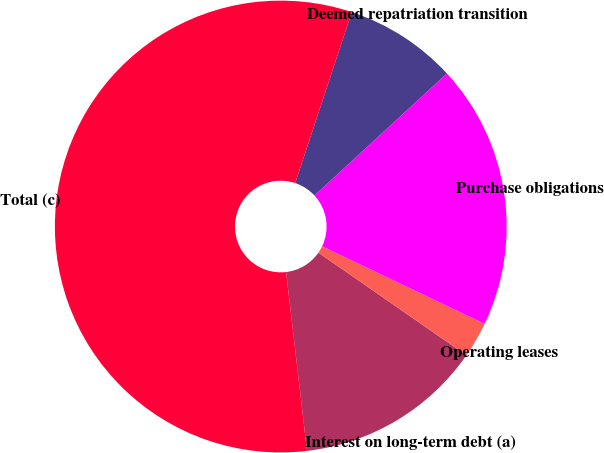Convert chart to OTSL. <chart><loc_0><loc_0><loc_500><loc_500><pie_chart><fcel>Interest on long-term debt (a)<fcel>Operating leases<fcel>Purchase obligations<fcel>Deemed repatriation transition<fcel>Total (c)<nl><fcel>13.5%<fcel>2.56%<fcel>18.94%<fcel>8.06%<fcel>56.95%<nl></chart> 